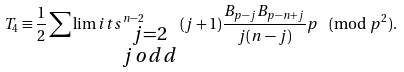Convert formula to latex. <formula><loc_0><loc_0><loc_500><loc_500>T _ { 4 } \equiv \frac { 1 } { 2 } \sum \lim i t s _ { \begin{smallmatrix} j = 2 \\ j \, o d d \end{smallmatrix} } ^ { n - 2 } ( j + 1 ) \frac { B _ { p - j } B _ { p - n + j } } { j ( n - j ) } p \pmod { p ^ { 2 } } .</formula> 